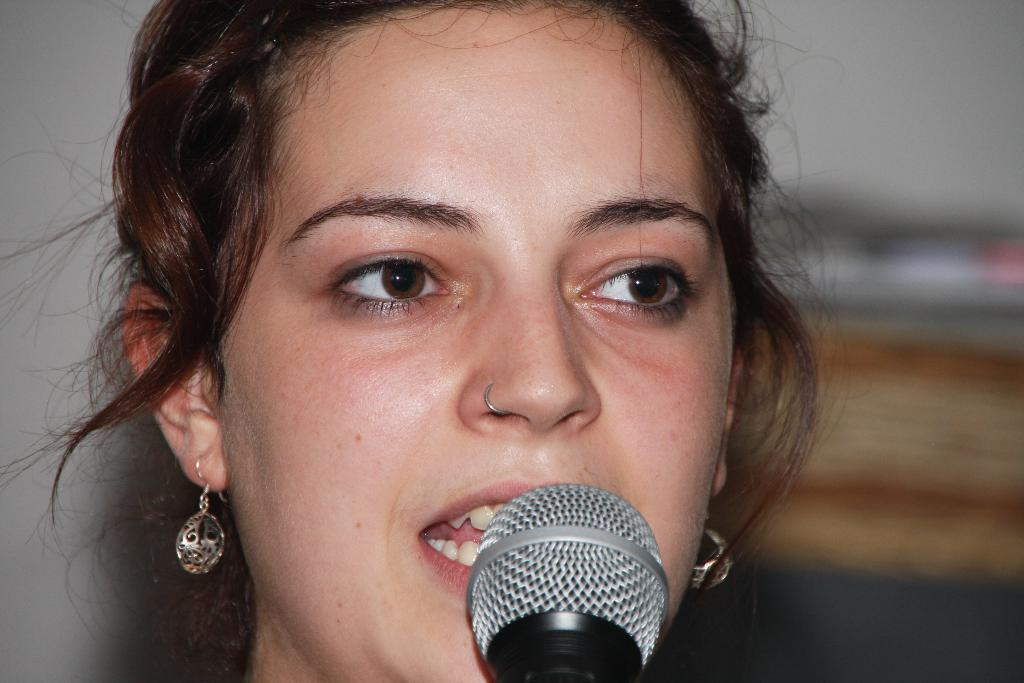What is the main subject of the image? There is a person's face in the image. What object is visible near the person's face? There is a microphone (mic) in the image. Can you describe the background of the image? The background of the image is blurred. Where is the cup placed in the image? There is no cup present in the image. Can you tell me the location of the map in the image? There is no map present in the image. 